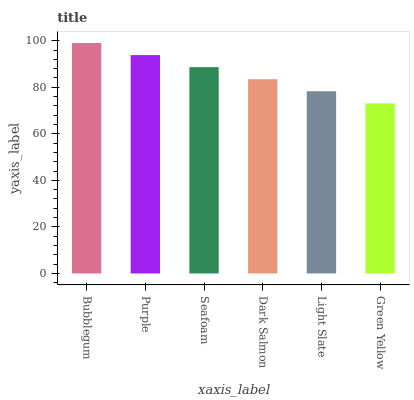Is Green Yellow the minimum?
Answer yes or no. Yes. Is Bubblegum the maximum?
Answer yes or no. Yes. Is Purple the minimum?
Answer yes or no. No. Is Purple the maximum?
Answer yes or no. No. Is Bubblegum greater than Purple?
Answer yes or no. Yes. Is Purple less than Bubblegum?
Answer yes or no. Yes. Is Purple greater than Bubblegum?
Answer yes or no. No. Is Bubblegum less than Purple?
Answer yes or no. No. Is Seafoam the high median?
Answer yes or no. Yes. Is Dark Salmon the low median?
Answer yes or no. Yes. Is Purple the high median?
Answer yes or no. No. Is Green Yellow the low median?
Answer yes or no. No. 